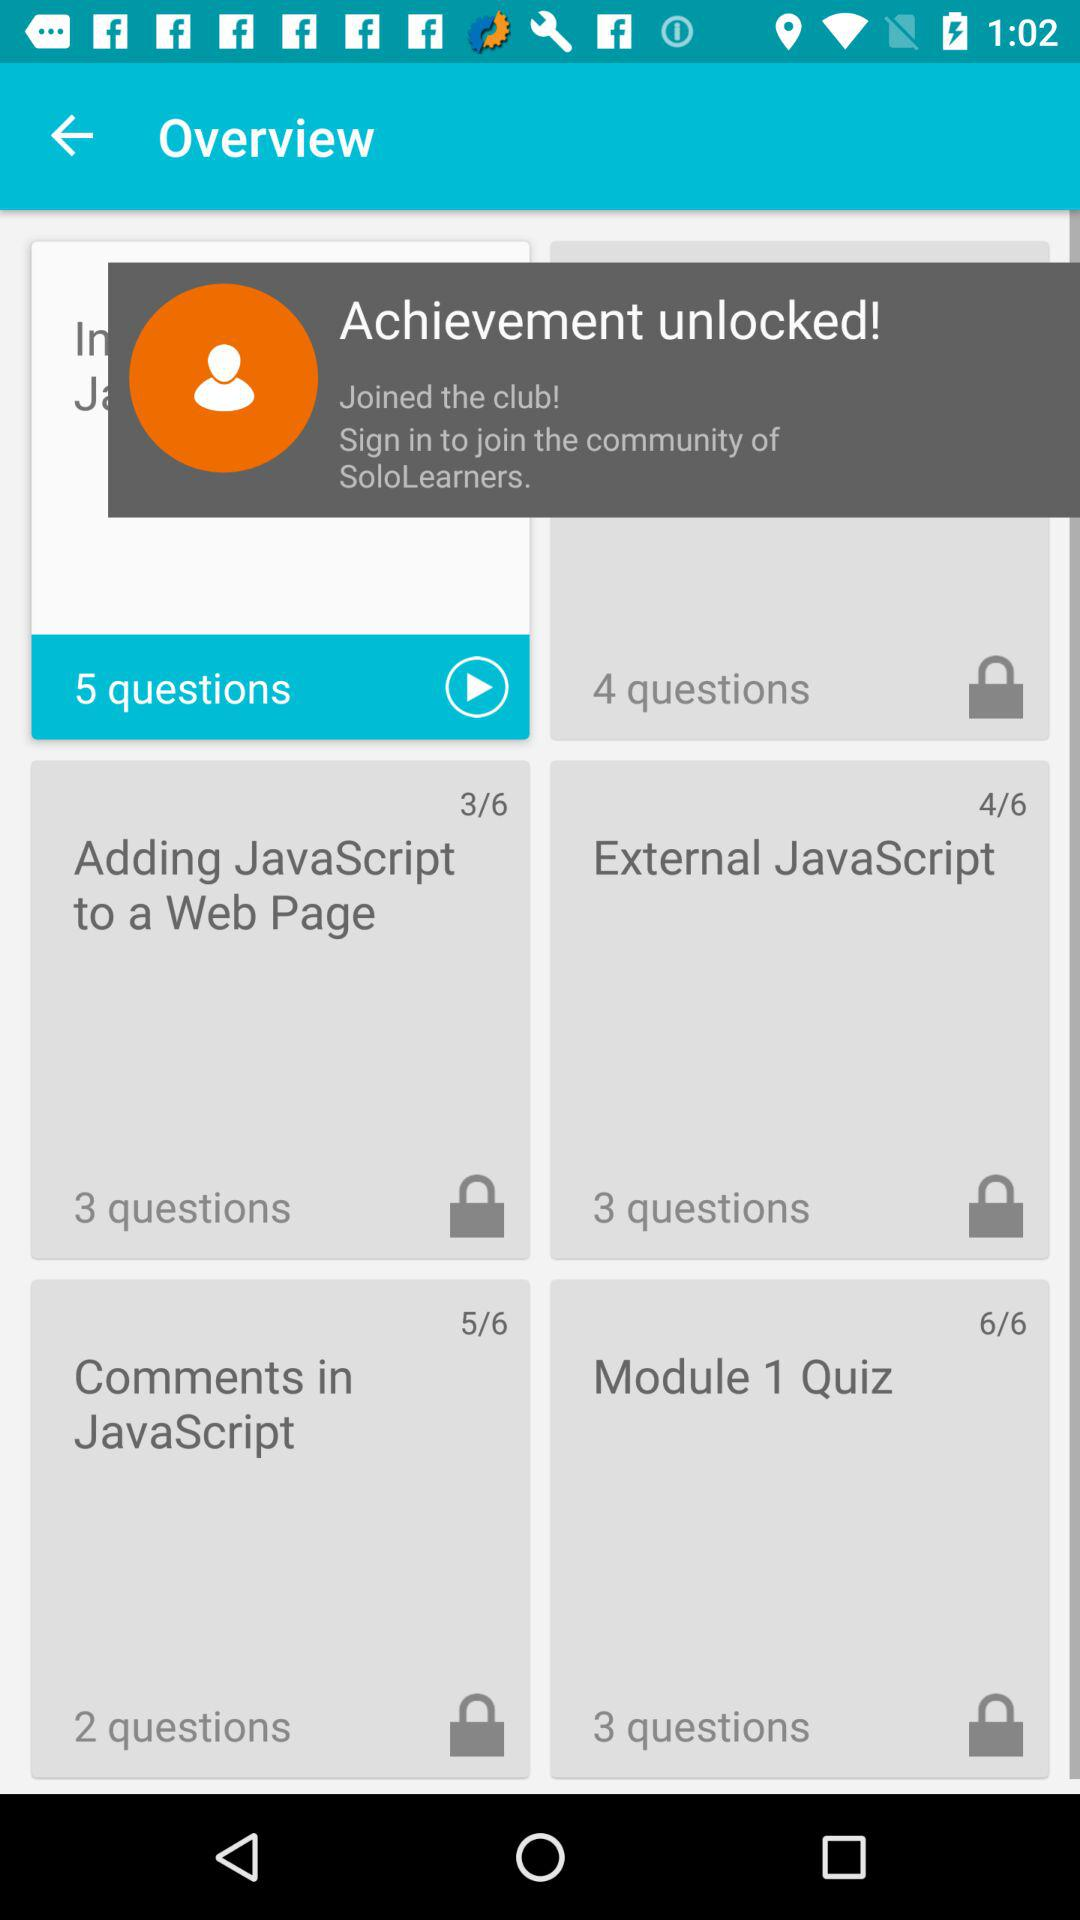Which course has 2 questions? The course is "Comments in JavaScript". 